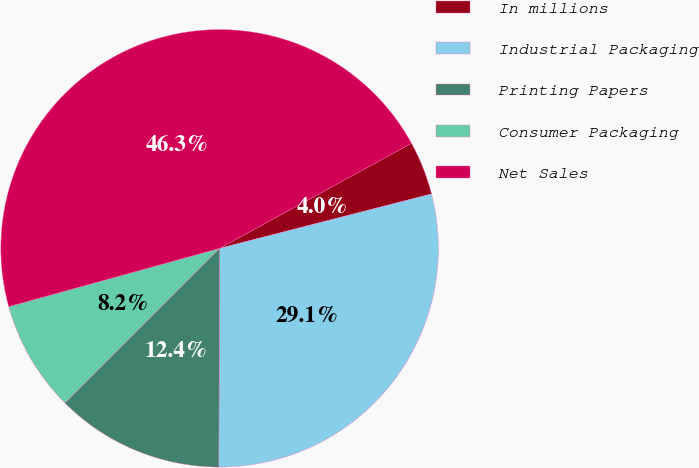Convert chart. <chart><loc_0><loc_0><loc_500><loc_500><pie_chart><fcel>In millions<fcel>Industrial Packaging<fcel>Printing Papers<fcel>Consumer Packaging<fcel>Net Sales<nl><fcel>3.97%<fcel>29.06%<fcel>12.44%<fcel>8.21%<fcel>46.32%<nl></chart> 